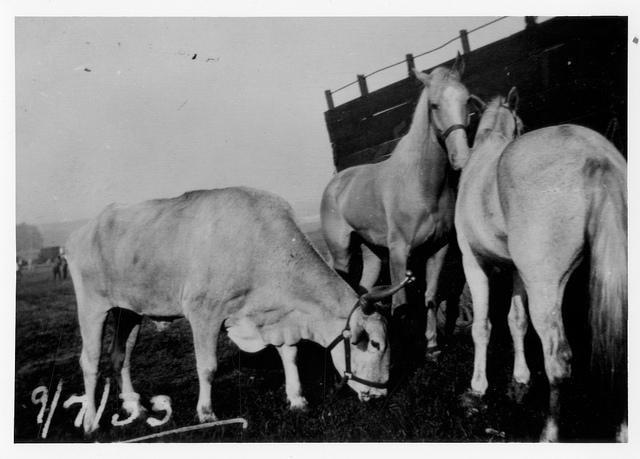How many horses are there?
Give a very brief answer. 2. How many cars in the picture are on the road?
Give a very brief answer. 0. 